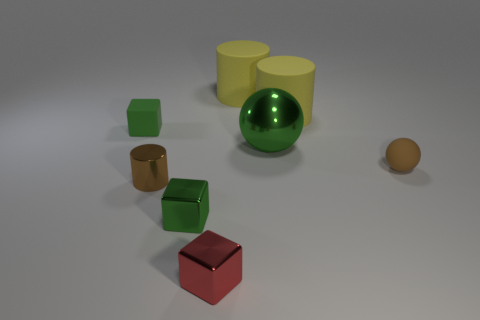The tiny rubber thing that is behind the tiny matte ball has what shape?
Ensure brevity in your answer.  Cube. Does the small brown shiny object have the same shape as the shiny thing that is behind the tiny brown rubber thing?
Keep it short and to the point. No. Are there the same number of yellow cylinders that are in front of the small matte cube and cylinders on the left side of the big green metallic ball?
Provide a succinct answer. No. There is a big thing that is the same color as the matte cube; what is its shape?
Give a very brief answer. Sphere. Is the color of the small matte object to the right of the tiny rubber cube the same as the cylinder in front of the tiny green rubber thing?
Keep it short and to the point. Yes. Is the number of brown spheres that are on the right side of the tiny matte cube greater than the number of small purple metal spheres?
Offer a very short reply. Yes. What material is the brown cylinder?
Make the answer very short. Metal. There is a tiny green object that is made of the same material as the tiny brown cylinder; what is its shape?
Provide a succinct answer. Cube. There is a green cube in front of the green cube behind the tiny rubber sphere; what size is it?
Your response must be concise. Small. What is the color of the block that is left of the metal cylinder?
Provide a succinct answer. Green. 